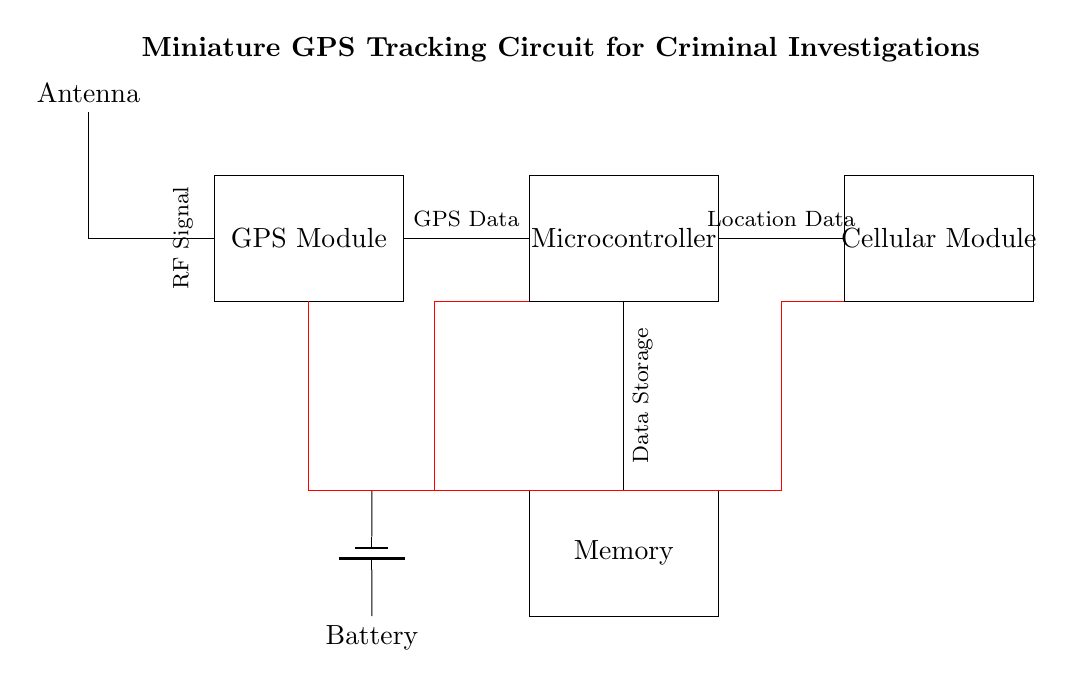what is the main purpose of this circuit? The circuit is designed for GPS tracking, specifically to study movement patterns in criminal investigations. This can be inferred from the labeled components and the title stating "Miniature GPS Tracking Circuit for Criminal Investigations."
Answer: GPS tracking how many main components are in this circuit? The circuit contains five main components: GPS Module, Microcontroller, Battery, Antenna, and Cellular Module, as indicated by the rectangles drawn for each component.
Answer: five what type of memory is used in this circuit? The diagram indicates a generic "Memory" block without further specification, but it is required for storing GPS data. Given the context, it is likely to refer to flash or an EEPROM type.
Answer: Memory which direction does the RF signal flow in this circuit? The RF signal flows from the antenna, which is positioned at the left, to the GPS Module, located next to it. The connection line indicates the direction of the signal.
Answer: to the GPS Module how is the battery connected to the Microcontroller? The battery is connected to the Microcontroller through a direct wire connection shown in red, highlighted as a power connection, from the battery's negative terminal to the Microcontroller.
Answer: direct wire connection what type of data is stored in the memory component? The memory component is labeled for data storage, indicating that it stores GPS data for tracking movements. This function makes it essential for retaining information about the tracked object’s location.
Answer: GPS data what secondary connection does the Cellular Module have? The Cellular Module has a connection from the Microcontroller to facilitate data transmission, indicating its role in sending location data via cellular networks.
Answer: from the Microcontroller 